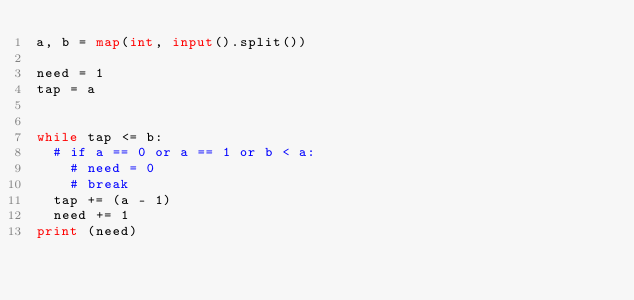Convert code to text. <code><loc_0><loc_0><loc_500><loc_500><_Python_>a, b = map(int, input().split())

need = 1
tap = a


while tap <= b:
	# if a == 0 or a == 1 or b < a:
		# need = 0
		# break
	tap += (a - 1)
	need += 1
print (need)</code> 